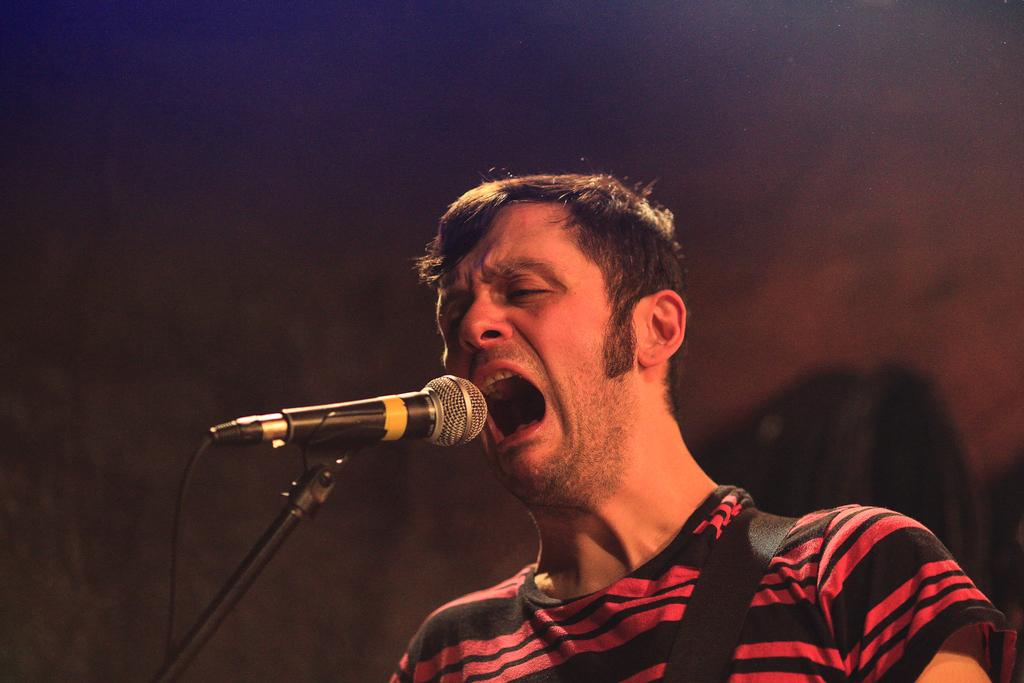Who is the main subject in the image? There is a man in the image. What is the man doing in the image? The man is standing and singing. What object is the man using while singing? The man is using a microphone. What type of chain is the man holding in the image? There is no chain present in the image. The man is using a microphone, not a chain. 